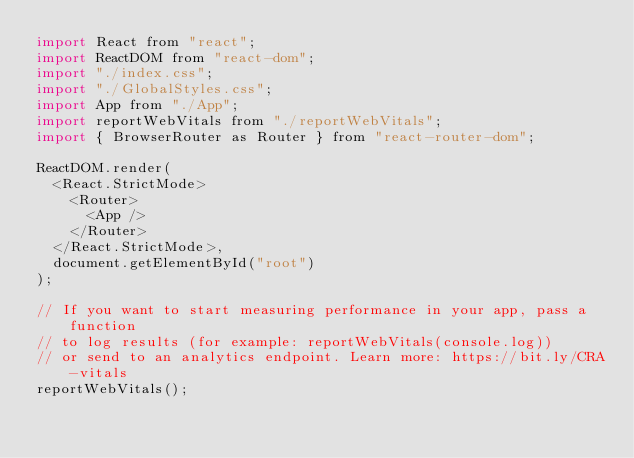Convert code to text. <code><loc_0><loc_0><loc_500><loc_500><_JavaScript_>import React from "react";
import ReactDOM from "react-dom";
import "./index.css";
import "./GlobalStyles.css";
import App from "./App";
import reportWebVitals from "./reportWebVitals";
import { BrowserRouter as Router } from "react-router-dom";

ReactDOM.render(
  <React.StrictMode>
    <Router>
      <App />
    </Router>
  </React.StrictMode>,
  document.getElementById("root")
);

// If you want to start measuring performance in your app, pass a function
// to log results (for example: reportWebVitals(console.log))
// or send to an analytics endpoint. Learn more: https://bit.ly/CRA-vitals
reportWebVitals();
</code> 